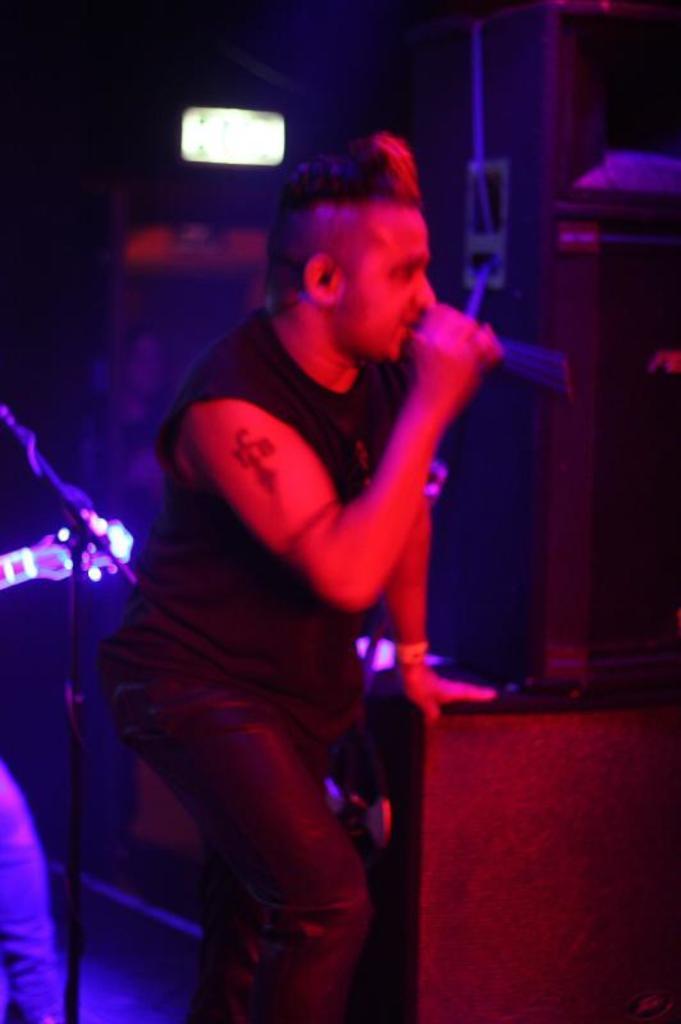How would you summarize this image in a sentence or two? In this picture, we can see a person holding a microphone and resting his hands on an object, and we can see some objects in bottom right side and left side of the picture, we can see the blurred background with a light. 